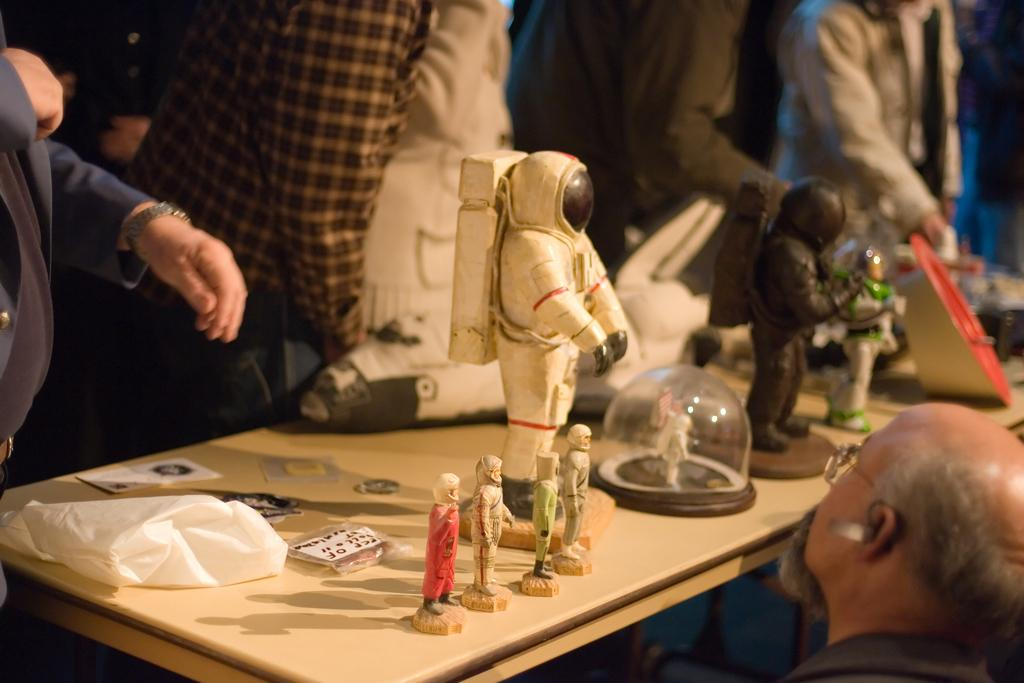What are the persons in the image wearing? The persons in the image are wearing clothes. What is located at the bottom of the image? There is a table at the bottom of the image. What can be found on the table? The table contains some toys and a plastic bag. What type of lettuce is visible on the table in the image? There is no lettuce present on the table in the image. How many cakes are being served by the persons in the image? There is no mention of cakes or any food being served in the image. 